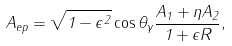<formula> <loc_0><loc_0><loc_500><loc_500>A _ { e p } = \sqrt { 1 - \epsilon ^ { 2 } } \cos \theta _ { \gamma } \frac { A _ { 1 } + \eta A _ { 2 } } { 1 + \epsilon R } ,</formula> 